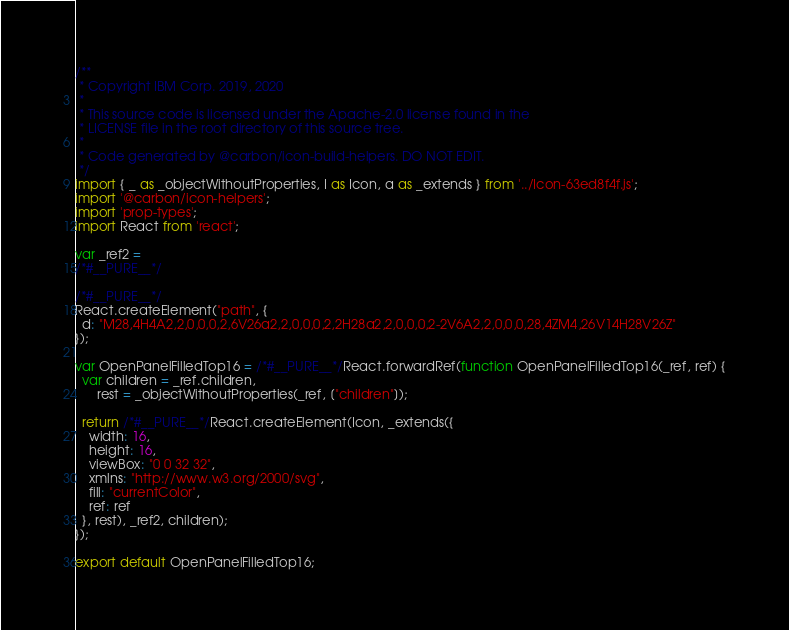<code> <loc_0><loc_0><loc_500><loc_500><_JavaScript_>/**
 * Copyright IBM Corp. 2019, 2020
 *
 * This source code is licensed under the Apache-2.0 license found in the
 * LICENSE file in the root directory of this source tree.
 *
 * Code generated by @carbon/icon-build-helpers. DO NOT EDIT.
 */
import { _ as _objectWithoutProperties, I as Icon, a as _extends } from '../Icon-63ed8f4f.js';
import '@carbon/icon-helpers';
import 'prop-types';
import React from 'react';

var _ref2 =
/*#__PURE__*/

/*#__PURE__*/
React.createElement("path", {
  d: "M28,4H4A2,2,0,0,0,2,6V26a2,2,0,0,0,2,2H28a2,2,0,0,0,2-2V6A2,2,0,0,0,28,4ZM4,26V14H28V26Z"
});

var OpenPanelFilledTop16 = /*#__PURE__*/React.forwardRef(function OpenPanelFilledTop16(_ref, ref) {
  var children = _ref.children,
      rest = _objectWithoutProperties(_ref, ["children"]);

  return /*#__PURE__*/React.createElement(Icon, _extends({
    width: 16,
    height: 16,
    viewBox: "0 0 32 32",
    xmlns: "http://www.w3.org/2000/svg",
    fill: "currentColor",
    ref: ref
  }, rest), _ref2, children);
});

export default OpenPanelFilledTop16;
</code> 